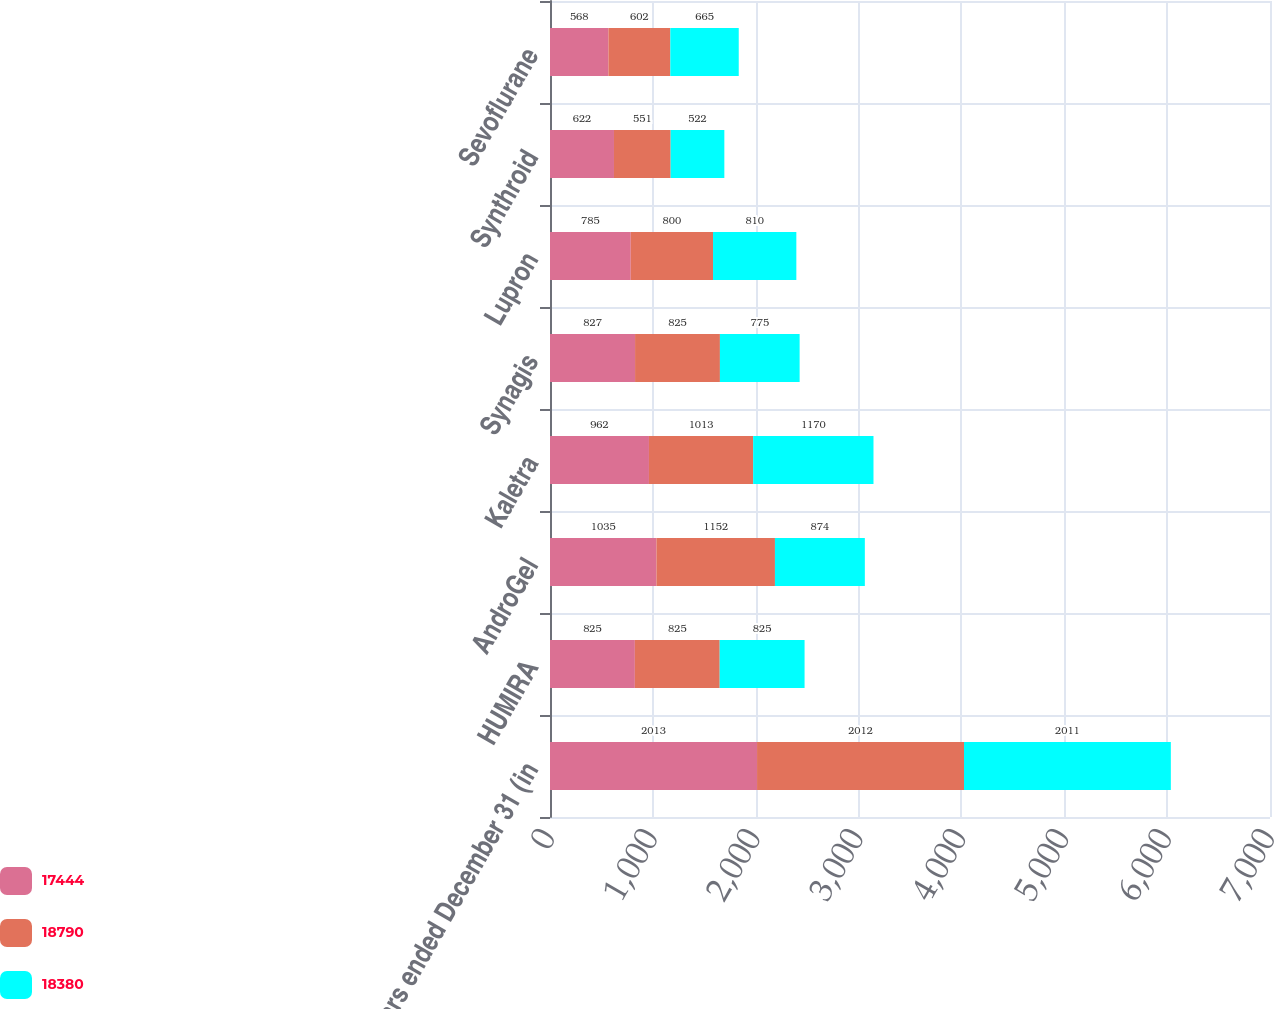Convert chart to OTSL. <chart><loc_0><loc_0><loc_500><loc_500><stacked_bar_chart><ecel><fcel>years ended December 31 (in<fcel>HUMIRA<fcel>AndroGel<fcel>Kaletra<fcel>Synagis<fcel>Lupron<fcel>Synthroid<fcel>Sevoflurane<nl><fcel>17444<fcel>2013<fcel>825<fcel>1035<fcel>962<fcel>827<fcel>785<fcel>622<fcel>568<nl><fcel>18790<fcel>2012<fcel>825<fcel>1152<fcel>1013<fcel>825<fcel>800<fcel>551<fcel>602<nl><fcel>18380<fcel>2011<fcel>825<fcel>874<fcel>1170<fcel>775<fcel>810<fcel>522<fcel>665<nl></chart> 